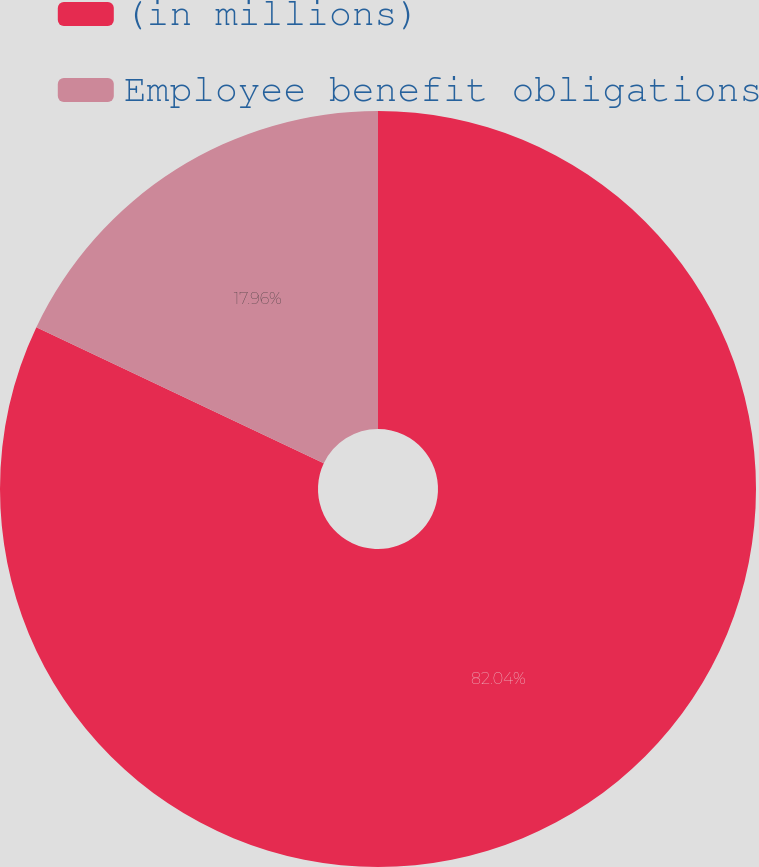<chart> <loc_0><loc_0><loc_500><loc_500><pie_chart><fcel>(in millions)<fcel>Employee benefit obligations<nl><fcel>82.04%<fcel>17.96%<nl></chart> 